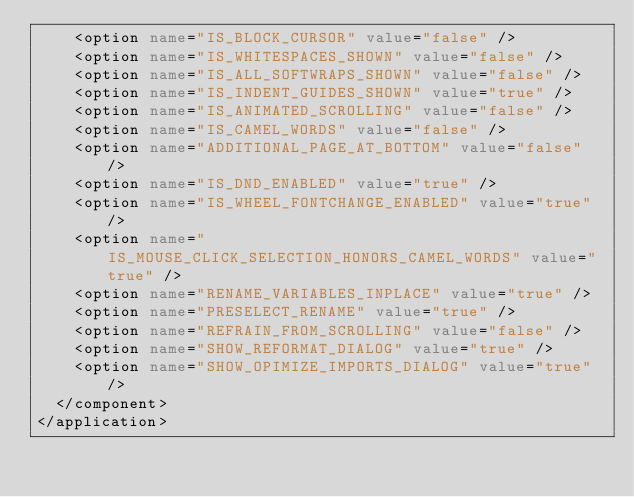Convert code to text. <code><loc_0><loc_0><loc_500><loc_500><_XML_>    <option name="IS_BLOCK_CURSOR" value="false" />
    <option name="IS_WHITESPACES_SHOWN" value="false" />
    <option name="IS_ALL_SOFTWRAPS_SHOWN" value="false" />
    <option name="IS_INDENT_GUIDES_SHOWN" value="true" />
    <option name="IS_ANIMATED_SCROLLING" value="false" />
    <option name="IS_CAMEL_WORDS" value="false" />
    <option name="ADDITIONAL_PAGE_AT_BOTTOM" value="false" />
    <option name="IS_DND_ENABLED" value="true" />
    <option name="IS_WHEEL_FONTCHANGE_ENABLED" value="true" />
    <option name="IS_MOUSE_CLICK_SELECTION_HONORS_CAMEL_WORDS" value="true" />
    <option name="RENAME_VARIABLES_INPLACE" value="true" />
    <option name="PRESELECT_RENAME" value="true" />
    <option name="REFRAIN_FROM_SCROLLING" value="false" />
    <option name="SHOW_REFORMAT_DIALOG" value="true" />
    <option name="SHOW_OPIMIZE_IMPORTS_DIALOG" value="true" />
  </component>
</application>

</code> 